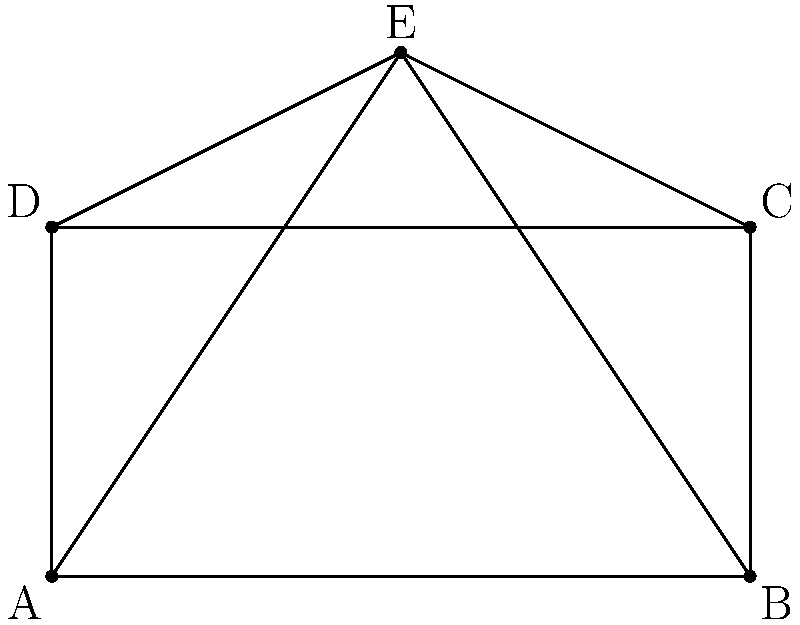Consider the simplified aircraft wing design shown in the diagram. What is the order of the symmetry group for this wing design, assuming it represents both the top and bottom surfaces? To determine the order of the symmetry group for this aircraft wing design, we need to identify all the symmetry operations that leave the shape unchanged. Let's analyze the design step-by-step:

1. Rotational symmetry:
   - The wing has 180° rotational symmetry around the center point E.
   - This accounts for 2 elements in the symmetry group (0° and 180° rotations).

2. Reflection symmetry:
   - There is a line of reflection along the vertical axis through point E.
   - This adds 1 more element to the symmetry group.

3. Identity:
   - The identity transformation (no change) is always part of a symmetry group.
   - This adds 1 more element to the symmetry group.

4. Combining symmetries:
   - The reflection followed by the 180° rotation is equivalent to the reflection itself.
   - The 180° rotation followed by the reflection is also equivalent to the reflection.
   - Therefore, no new elements are added by combining these symmetries.

In total, we have identified 4 distinct symmetry operations:
1. Identity
2. 180° rotation
3. Reflection
4. 180° rotation followed by reflection (equivalent to reflection alone)

The order of a group is the number of distinct elements it contains. Therefore, the order of the symmetry group for this aircraft wing design is 4.

This group is isomorphic to the Klein four-group, also known as $V_4$ or $C_2 \times C_2$, which is an important concept in group theory and has applications in various fields, including aircraft design and regulatory compliance.
Answer: 4 